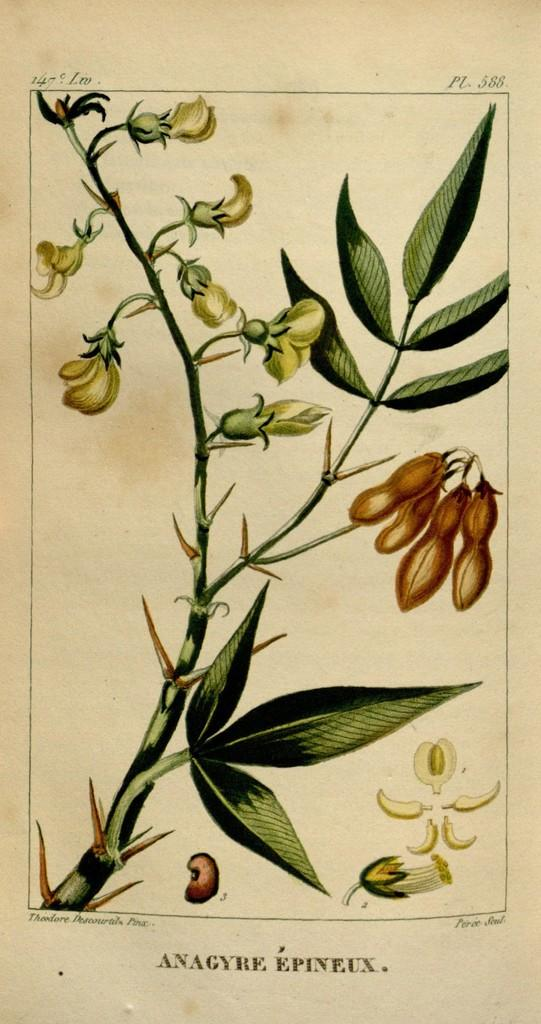What is depicted on the poster in the image? There is a poster of a plant in the image. What specific elements of the plant are shown on the poster? The poster contains flowers and leaves. Are there any words on the poster? Yes, there are words written on the poster. How many laborers are working on the poster? There are no laborers depicted on the poster; it features a plant with flowers and leaves. Can you give me an example of an ant on the poster? There are no ants present on the poster; it only contains a plant with flowers and leaves, along with words. 